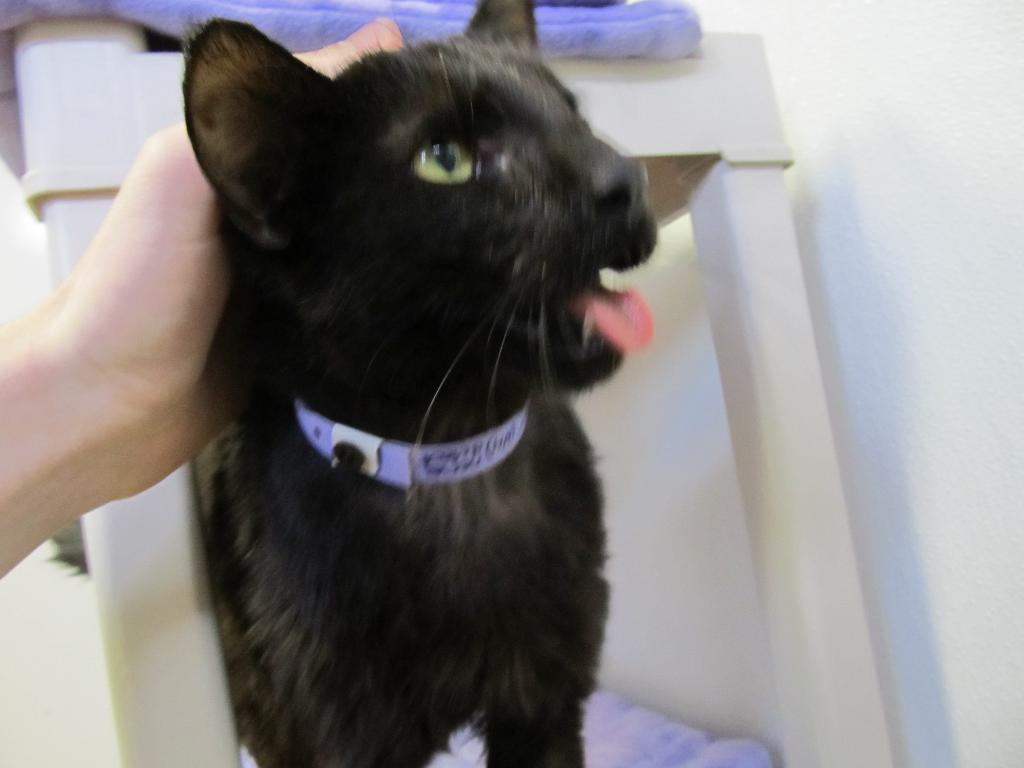What type of animal is in the image? There is a black cat in the image. What can be seen near the cat? There is a person's hand above the cat. What is the color of the background in the image? The background is a white wall. What scientific theory is being discussed in the image? There is no indication in the image that a scientific theory is being discussed. 